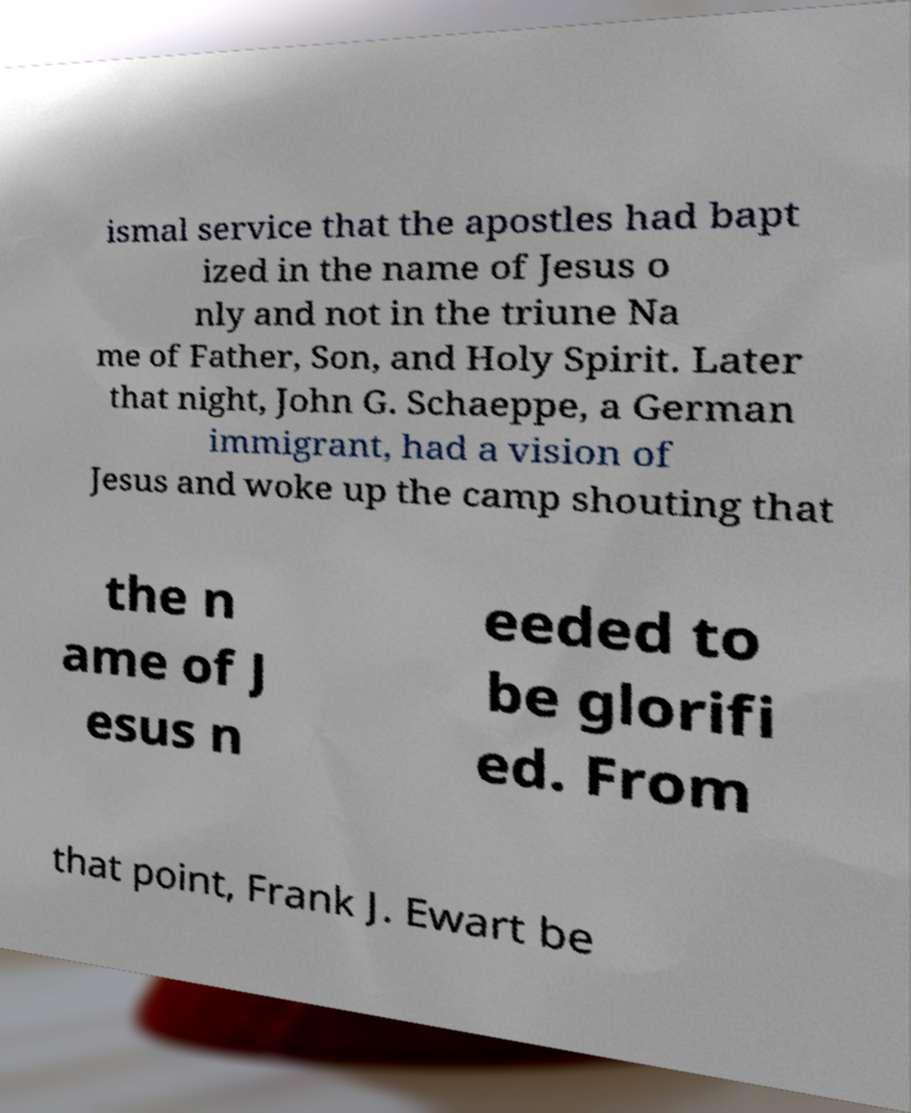Can you accurately transcribe the text from the provided image for me? ismal service that the apostles had bapt ized in the name of Jesus o nly and not in the triune Na me of Father, Son, and Holy Spirit. Later that night, John G. Schaeppe, a German immigrant, had a vision of Jesus and woke up the camp shouting that the n ame of J esus n eeded to be glorifi ed. From that point, Frank J. Ewart be 